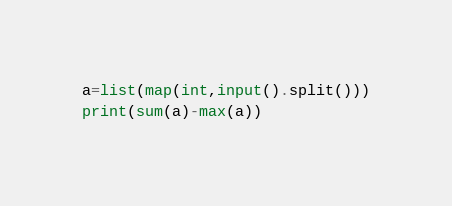<code> <loc_0><loc_0><loc_500><loc_500><_Python_>a=list(map(int,input().split()))
print(sum(a)-max(a))</code> 